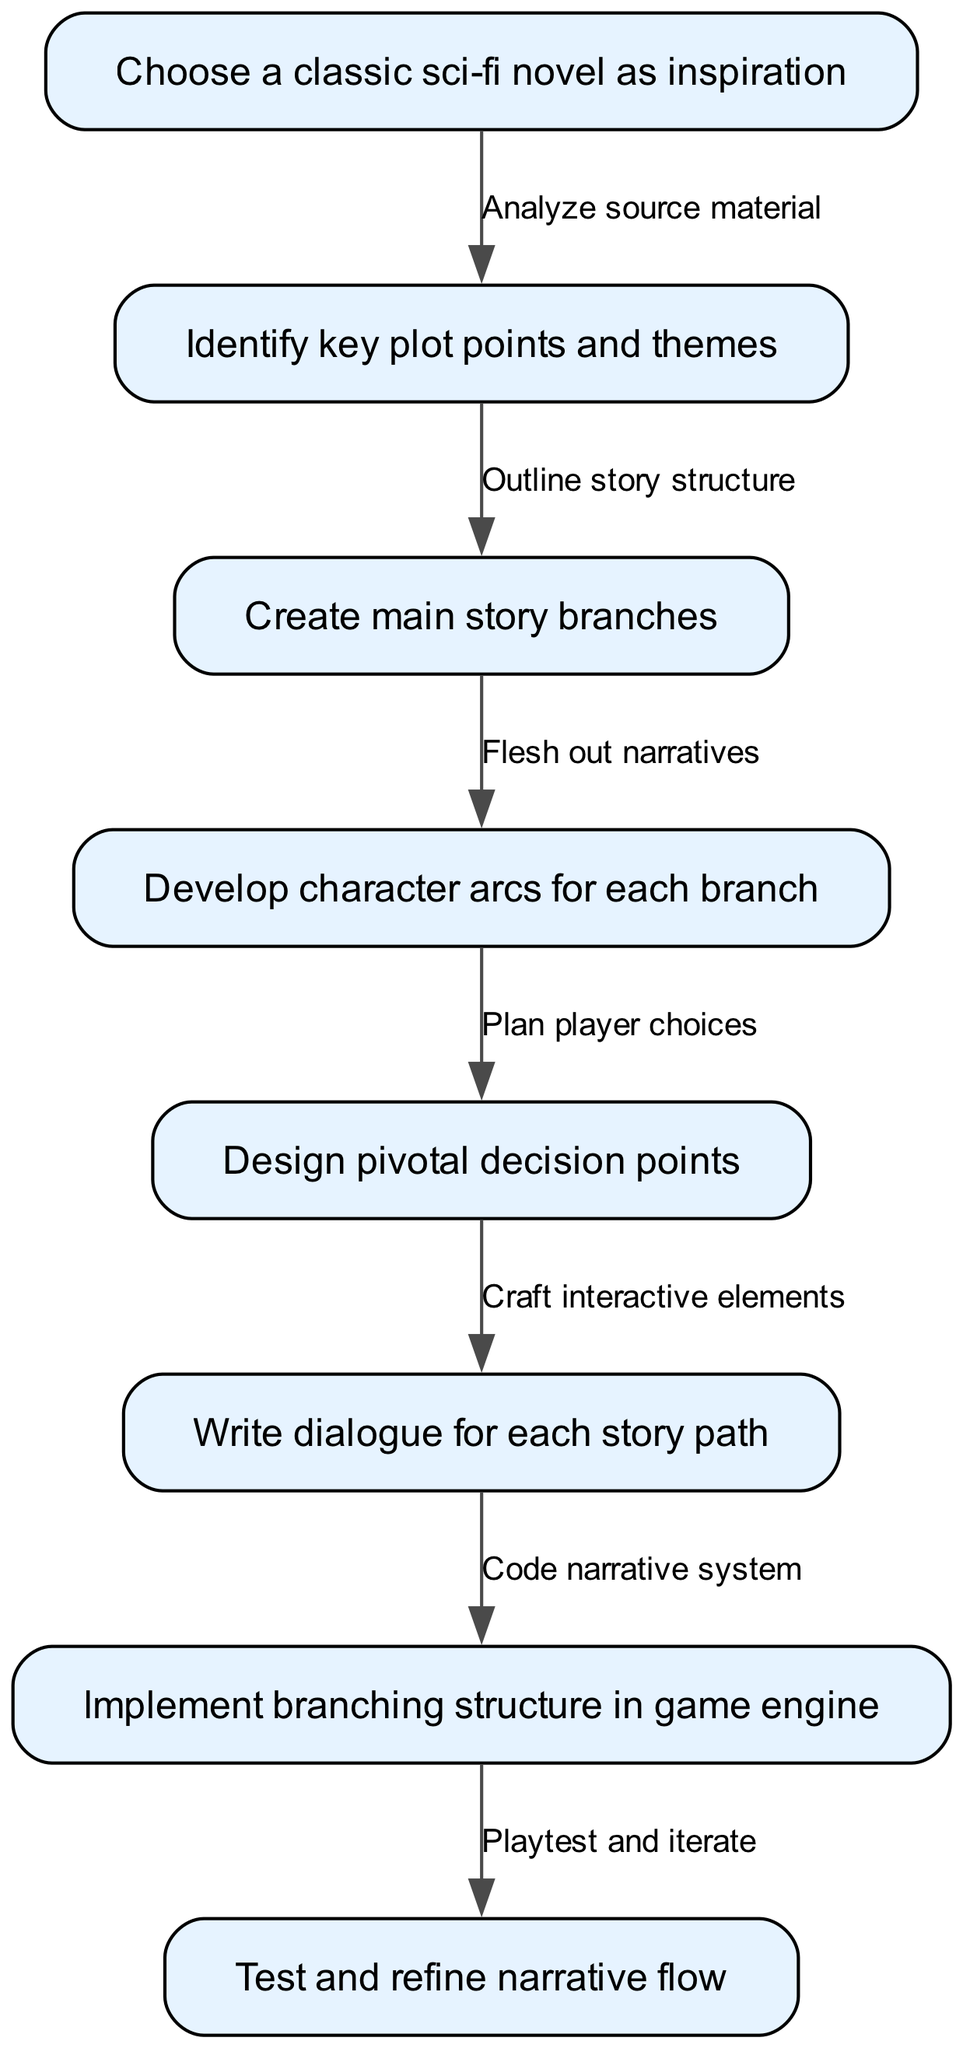What is the first step in crafting a branching narrative structure? The first step is to "Choose a classic sci-fi novel as inspiration." This is clearly depicted in node 1 of the diagram.
Answer: Choose a classic sci-fi novel as inspiration How many main story branches are created in this process? According to the diagram, there is a dedicated step labeled "Create main story branches," which indicates that this is the third step in the sequence. Therefore, the number of main story branches is not specified directly by a number but is implied to follow after identifying key plot points and themes.
Answer: Not specified What is the connection between identifying key plot points and creating main story branches? The diagram shows that after "Identify key plot points and themes," the next step is to "Create main story branches." This indicates a direct progression from understanding the source material to the outlining of the story structure.
Answer: Outline story structure Which step involves developing character arcs? The step that corresponds to developing character arcs is "Develop character arcs for each branch." This is clearly labeled as the fourth step in the diagram.
Answer: Develop character arcs for each branch What comes after writing dialogue for each story path? According to the flow chart, "Implement branching structure in game engine" follows after the step "Write dialogue for each story path." This shows the progression from writing into implementation.
Answer: Implement branching structure in game engine How many edges are there in the diagram? By counting the connections between nodes, we see there are seven edges, which represent the relationships between each of the steps in the process.
Answer: Seven What is the last step in testing the narrative flow? The final step in the diagram is "Test and refine narrative flow." This is indicated as the eighth step, showing it’s the last part of the process for crafting the narrative.
Answer: Test and refine narrative flow What links the planning of player choices to writing dialogue? The connection shows that after developing character arcs, the next step is to "Design pivotal decision points," which then leads to "Write dialogue for each story path." This indicates that solid choices are a prerequisite for writing relevant dialogue.
Answer: Craft interactive elements What action follows after coding the narrative system? After "Code narrative system" (node 6), the next step is "Playtest and iterate" (node 8), indicating that the focus shifts to refining gameplay once coding is complete.
Answer: Playtest and iterate 